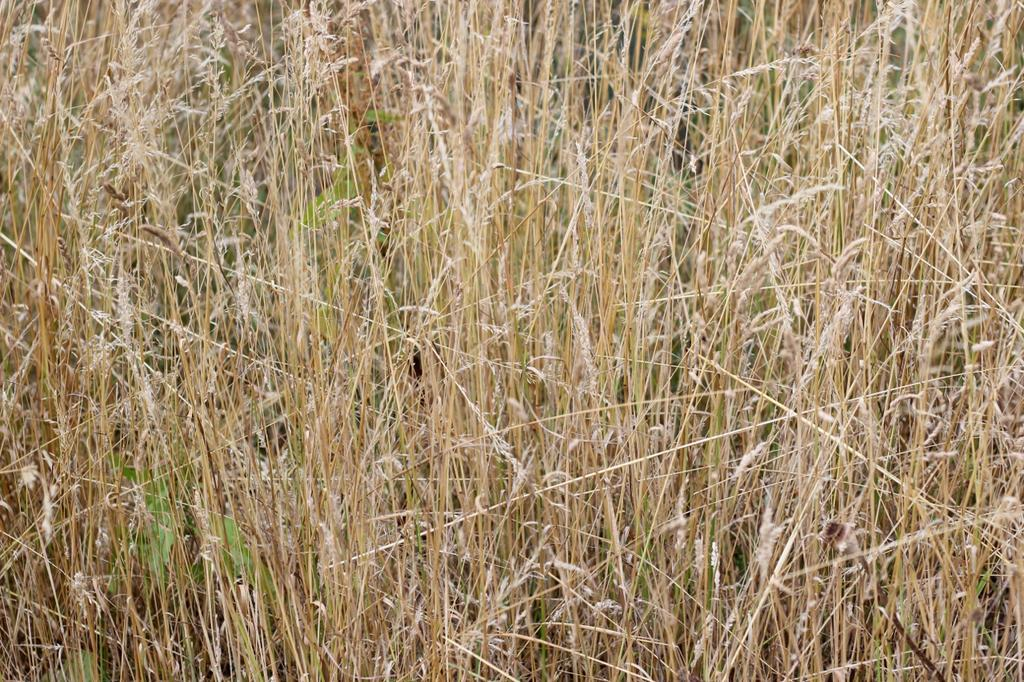What type of vegetation is present in the image? There is a large amount of dried grass in the image. What type of business is being conducted in the image? There is no indication of a business or any commercial activity in the image; it features a large amount of dried grass. What plot of land is depicted in the image? The image does not show a specific plot of land; it simply features a large amount of dried grass. 